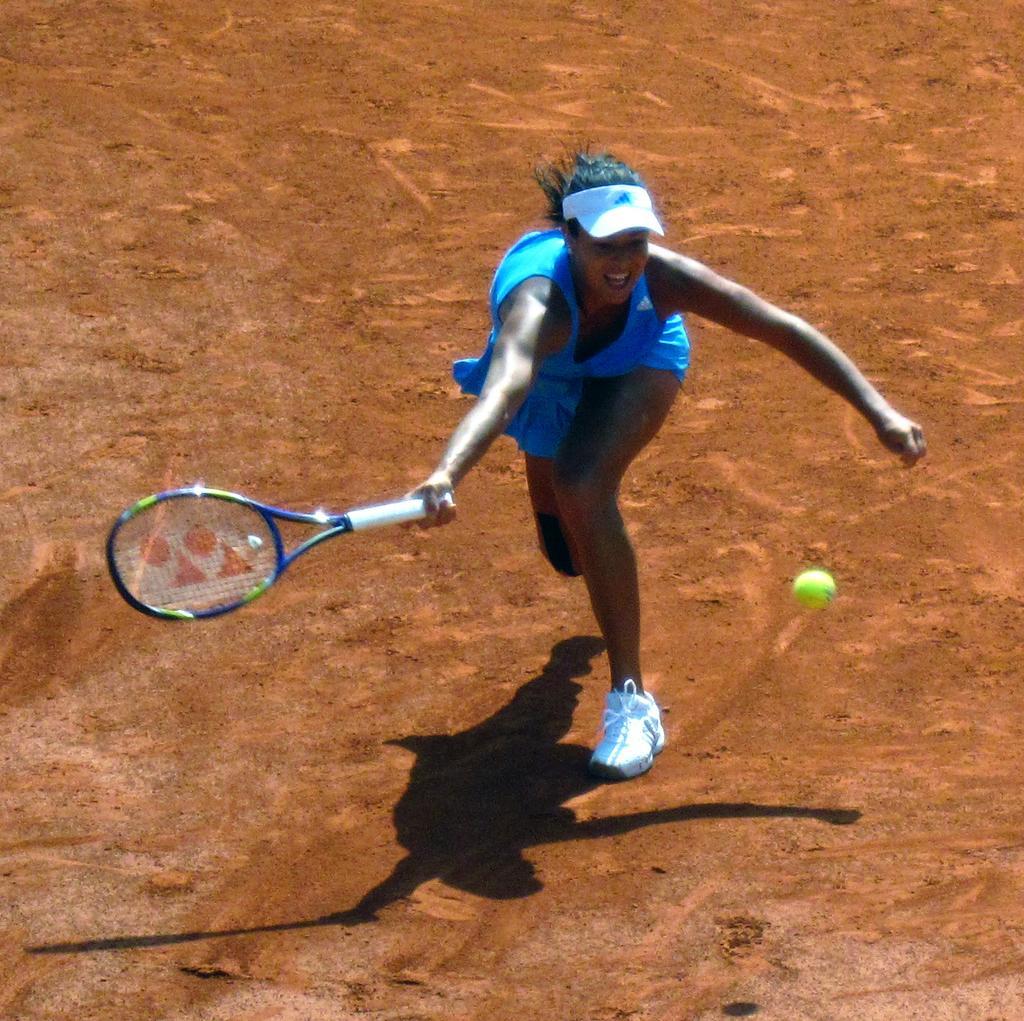Could you give a brief overview of what you see in this image? In this image i can see a playground. on the center a woman wearing a blue color skirt and wearing white shoes and wearing a cap on her head and there is a green color ball on the right side. she holding a bat on the left side of her hand. there is a shadow of the woman on the playground. 